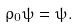<formula> <loc_0><loc_0><loc_500><loc_500>\rho _ { 0 } \psi = \psi .</formula> 